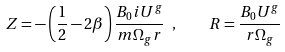Convert formula to latex. <formula><loc_0><loc_0><loc_500><loc_500>Z = - \left ( \frac { 1 } { 2 } - 2 \beta \right ) \frac { B _ { 0 } i U ^ { g } } { m \Omega _ { g } r } \ , \quad R = \frac { B _ { 0 } U ^ { g } } { r \Omega _ { g } }</formula> 